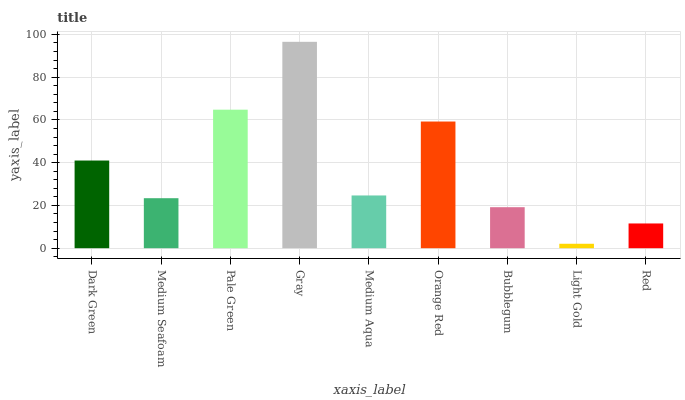Is Light Gold the minimum?
Answer yes or no. Yes. Is Gray the maximum?
Answer yes or no. Yes. Is Medium Seafoam the minimum?
Answer yes or no. No. Is Medium Seafoam the maximum?
Answer yes or no. No. Is Dark Green greater than Medium Seafoam?
Answer yes or no. Yes. Is Medium Seafoam less than Dark Green?
Answer yes or no. Yes. Is Medium Seafoam greater than Dark Green?
Answer yes or no. No. Is Dark Green less than Medium Seafoam?
Answer yes or no. No. Is Medium Aqua the high median?
Answer yes or no. Yes. Is Medium Aqua the low median?
Answer yes or no. Yes. Is Bubblegum the high median?
Answer yes or no. No. Is Gray the low median?
Answer yes or no. No. 